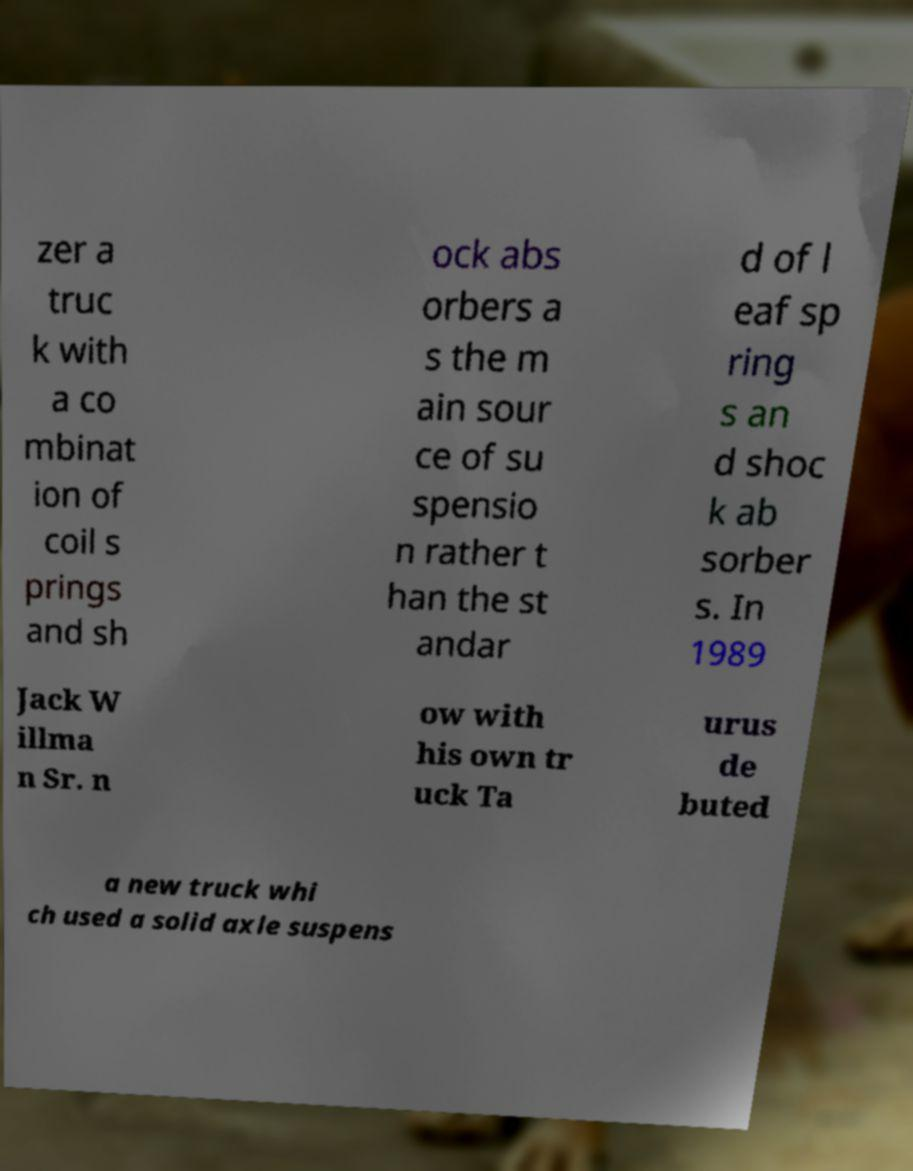Please identify and transcribe the text found in this image. zer a truc k with a co mbinat ion of coil s prings and sh ock abs orbers a s the m ain sour ce of su spensio n rather t han the st andar d of l eaf sp ring s an d shoc k ab sorber s. In 1989 Jack W illma n Sr. n ow with his own tr uck Ta urus de buted a new truck whi ch used a solid axle suspens 